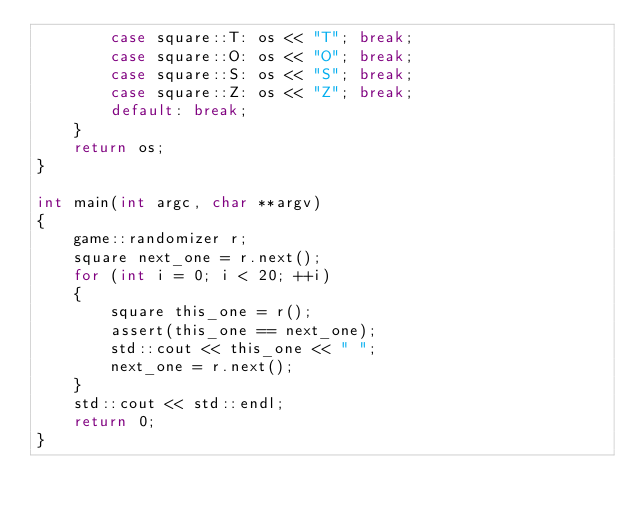Convert code to text. <code><loc_0><loc_0><loc_500><loc_500><_C++_>        case square::T: os << "T"; break;
        case square::O: os << "O"; break;
        case square::S: os << "S"; break;
        case square::Z: os << "Z"; break;
        default: break;
    }
    return os;
}

int main(int argc, char **argv)
{
    game::randomizer r;
    square next_one = r.next();
    for (int i = 0; i < 20; ++i)
    {
        square this_one = r();
        assert(this_one == next_one);
        std::cout << this_one << " ";
        next_one = r.next();
    }
    std::cout << std::endl;
    return 0;
}
</code> 